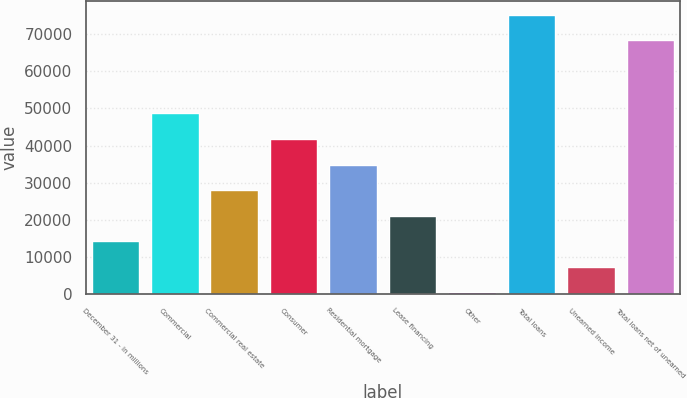<chart> <loc_0><loc_0><loc_500><loc_500><bar_chart><fcel>December 31 - in millions<fcel>Commercial<fcel>Commercial real estate<fcel>Consumer<fcel>Residential mortgage<fcel>Lease financing<fcel>Other<fcel>Total loans<fcel>Unearned income<fcel>Total loans net of unearned<nl><fcel>14192.2<fcel>48640.2<fcel>27971.4<fcel>41750.6<fcel>34861<fcel>21081.8<fcel>413<fcel>75208.6<fcel>7302.6<fcel>68319<nl></chart> 